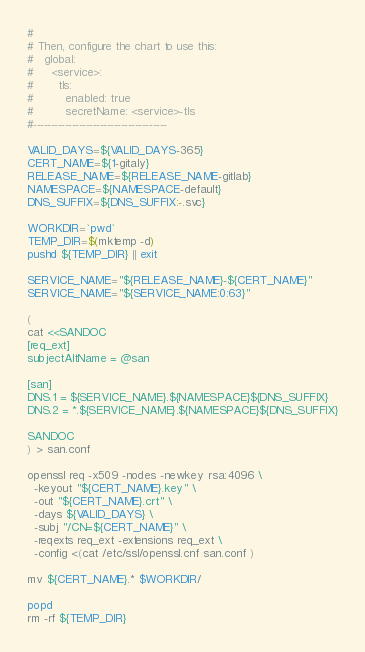Convert code to text. <code><loc_0><loc_0><loc_500><loc_500><_Bash_>#
# Then, configure the chart to use this:
#   global:
#     <service>:
#       tls:
#         enabled: true
#         secretName: <service>-tls
#--------------------------------------

VALID_DAYS=${VALID_DAYS-365}
CERT_NAME=${1-gitaly}
RELEASE_NAME=${RELEASE_NAME-gitlab}
NAMESPACE=${NAMESPACE-default}
DNS_SUFFIX=${DNS_SUFFIX:-.svc}

WORKDIR=`pwd`
TEMP_DIR=$(mktemp -d)
pushd ${TEMP_DIR} || exit

SERVICE_NAME="${RELEASE_NAME}-${CERT_NAME}"
SERVICE_NAME="${SERVICE_NAME:0:63}"

(
cat <<SANDOC
[req_ext]
subjectAltName = @san

[san]
DNS.1 = ${SERVICE_NAME}.${NAMESPACE}${DNS_SUFFIX}
DNS.2 = *.${SERVICE_NAME}.${NAMESPACE}${DNS_SUFFIX}

SANDOC
) > san.conf

openssl req -x509 -nodes -newkey rsa:4096 \
  -keyout "${CERT_NAME}.key" \
  -out "${CERT_NAME}.crt" \
  -days ${VALID_DAYS} \
  -subj "/CN=${CERT_NAME}" \
  -reqexts req_ext -extensions req_ext \
  -config <(cat /etc/ssl/openssl.cnf san.conf )

mv ${CERT_NAME}.* $WORKDIR/

popd
rm -rf ${TEMP_DIR}
</code> 